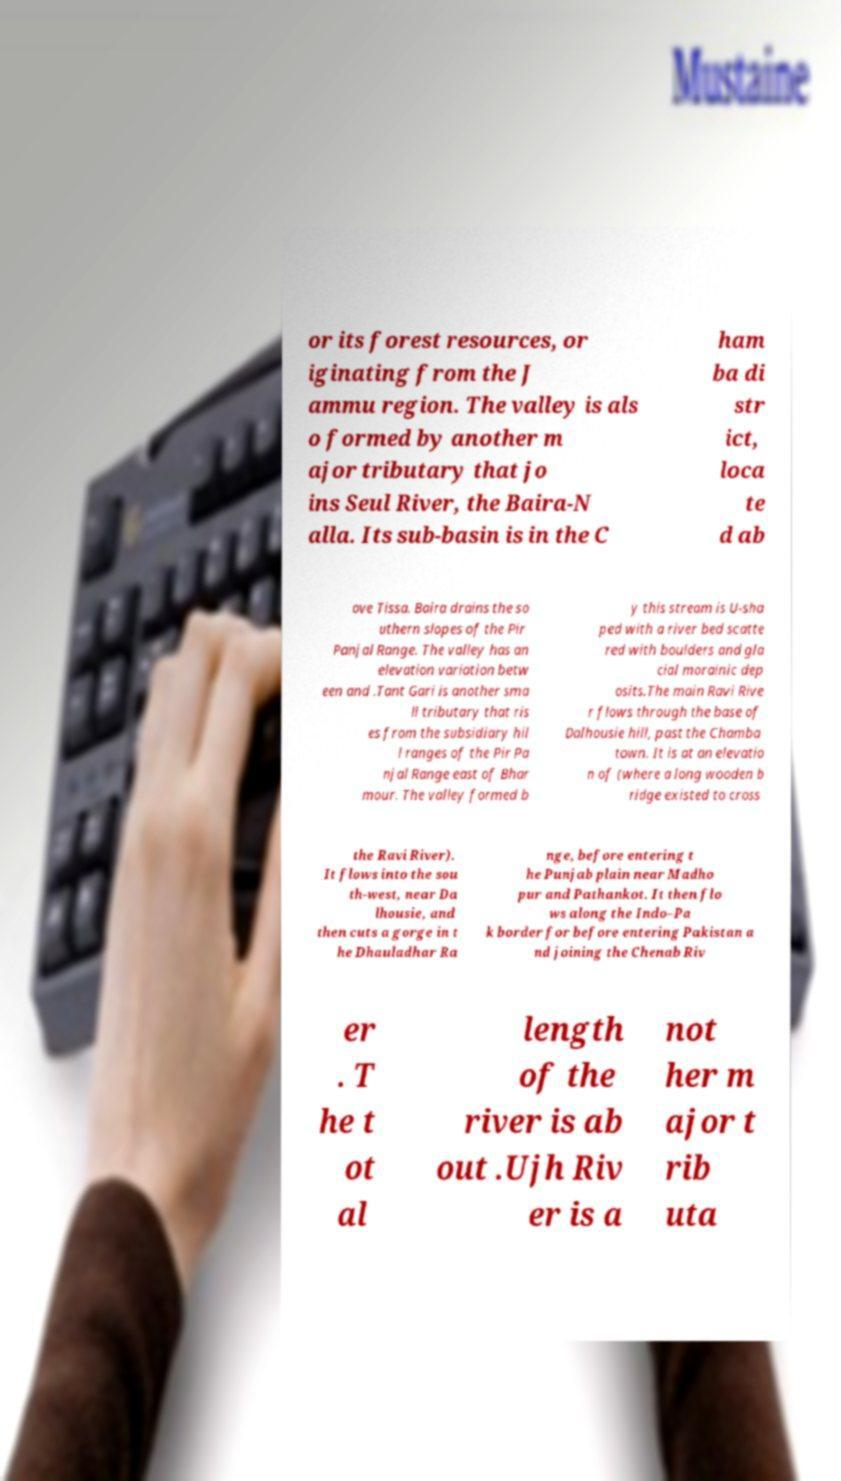Could you assist in decoding the text presented in this image and type it out clearly? or its forest resources, or iginating from the J ammu region. The valley is als o formed by another m ajor tributary that jo ins Seul River, the Baira-N alla. Its sub-basin is in the C ham ba di str ict, loca te d ab ove Tissa. Baira drains the so uthern slopes of the Pir Panjal Range. The valley has an elevation variation betw een and .Tant Gari is another sma ll tributary that ris es from the subsidiary hil l ranges of the Pir Pa njal Range east of Bhar mour. The valley formed b y this stream is U-sha ped with a river bed scatte red with boulders and gla cial morainic dep osits.The main Ravi Rive r flows through the base of Dalhousie hill, past the Chamba town. It is at an elevatio n of (where a long wooden b ridge existed to cross the Ravi River). It flows into the sou th-west, near Da lhousie, and then cuts a gorge in t he Dhauladhar Ra nge, before entering t he Punjab plain near Madho pur and Pathankot. It then flo ws along the Indo–Pa k border for before entering Pakistan a nd joining the Chenab Riv er . T he t ot al length of the river is ab out .Ujh Riv er is a not her m ajor t rib uta 